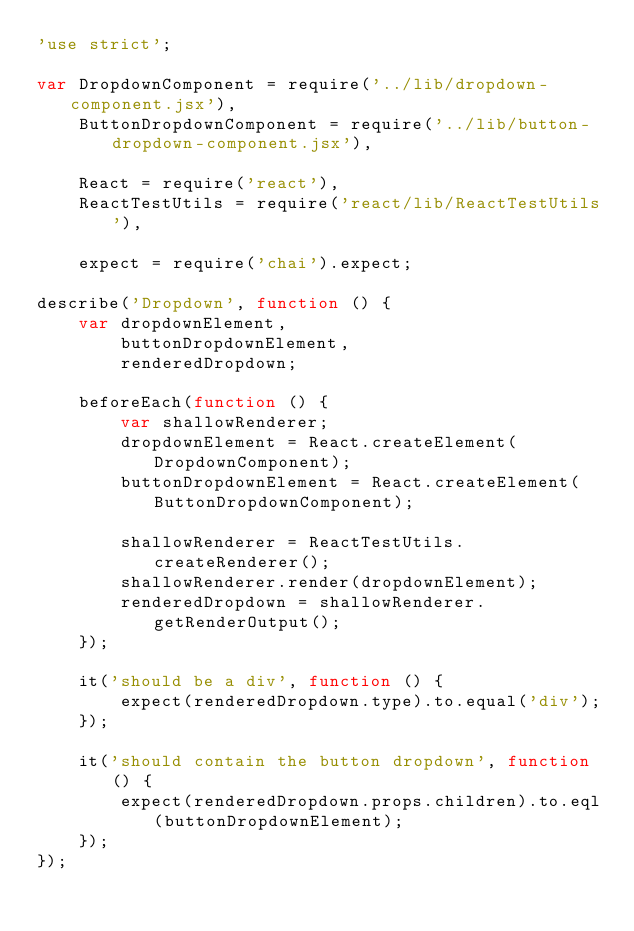<code> <loc_0><loc_0><loc_500><loc_500><_JavaScript_>'use strict';

var DropdownComponent = require('../lib/dropdown-component.jsx'),
    ButtonDropdownComponent = require('../lib/button-dropdown-component.jsx'),

    React = require('react'),
    ReactTestUtils = require('react/lib/ReactTestUtils'),

    expect = require('chai').expect;

describe('Dropdown', function () {
    var dropdownElement,
        buttonDropdownElement,
        renderedDropdown;

    beforeEach(function () {
        var shallowRenderer;
        dropdownElement = React.createElement(DropdownComponent);
        buttonDropdownElement = React.createElement(ButtonDropdownComponent);

        shallowRenderer = ReactTestUtils.createRenderer();
        shallowRenderer.render(dropdownElement);
        renderedDropdown = shallowRenderer.getRenderOutput();
    });

    it('should be a div', function () {
        expect(renderedDropdown.type).to.equal('div');
    });

    it('should contain the button dropdown', function () {
        expect(renderedDropdown.props.children).to.eql(buttonDropdownElement);
    });
});
</code> 